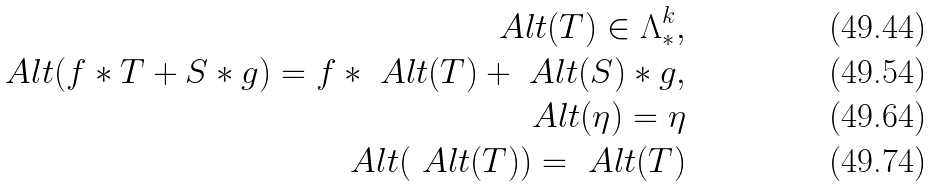<formula> <loc_0><loc_0><loc_500><loc_500>\ A l t ( T ) \in \Lambda ^ { k } _ { * } , \\ \ A l t ( f * T + S * g ) = f * \ A l t ( T ) + \ A l t ( S ) * g , \\ \ A l t ( \eta ) = \eta \\ \ A l t ( \ A l t ( T ) ) = \ A l t ( T )</formula> 